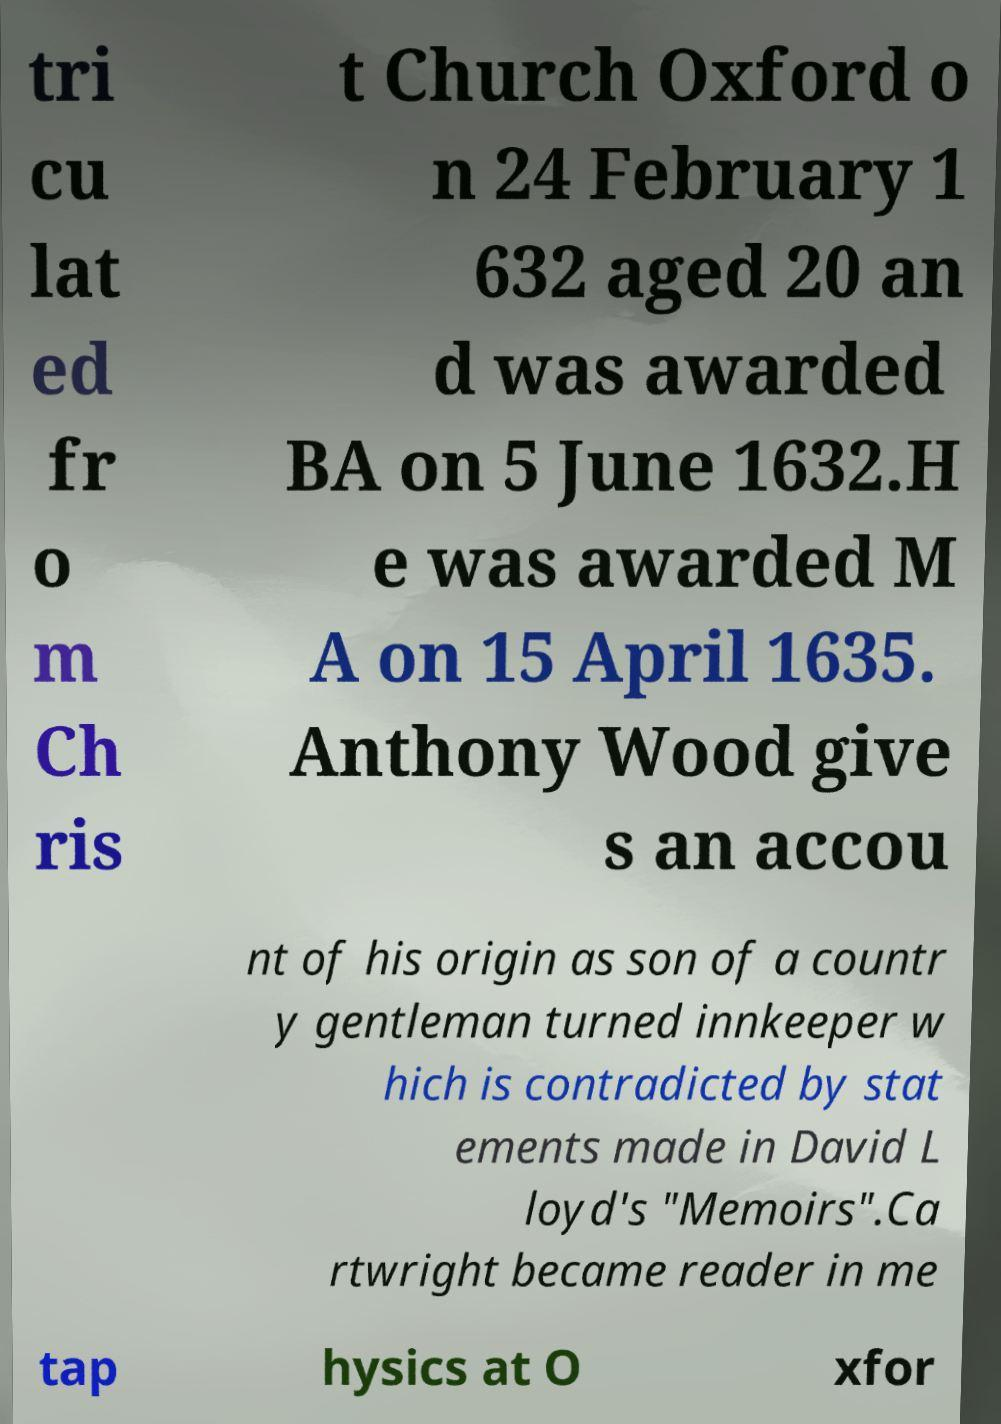There's text embedded in this image that I need extracted. Can you transcribe it verbatim? tri cu lat ed fr o m Ch ris t Church Oxford o n 24 February 1 632 aged 20 an d was awarded BA on 5 June 1632.H e was awarded M A on 15 April 1635. Anthony Wood give s an accou nt of his origin as son of a countr y gentleman turned innkeeper w hich is contradicted by stat ements made in David L loyd's "Memoirs".Ca rtwright became reader in me tap hysics at O xfor 